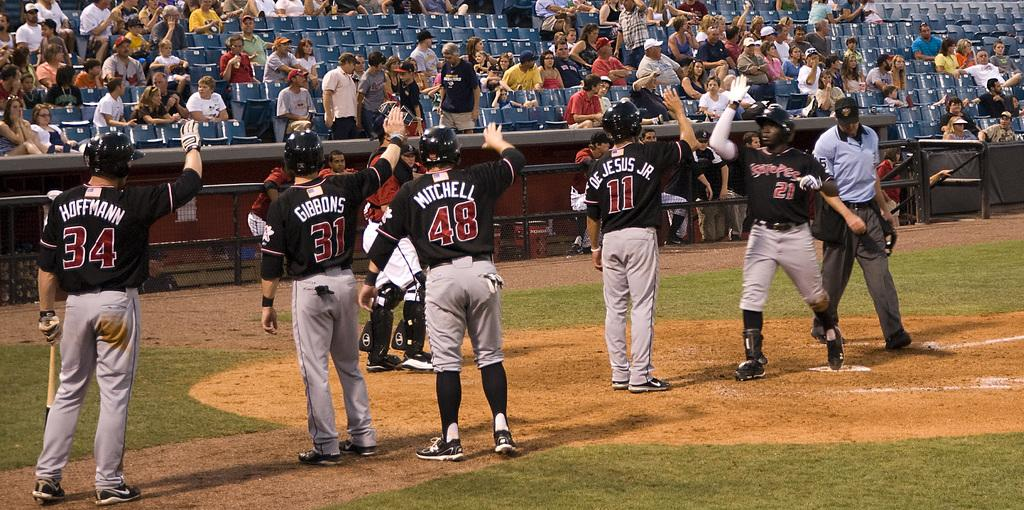<image>
Render a clear and concise summary of the photo. The player with the last name Mitchell is wearing number 48. 